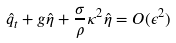<formula> <loc_0><loc_0><loc_500><loc_500>\hat { q } _ { t } + g \hat { \eta } + \frac { \sigma } { \rho } \kappa ^ { 2 } \hat { \eta } = O ( \epsilon ^ { 2 } )</formula> 